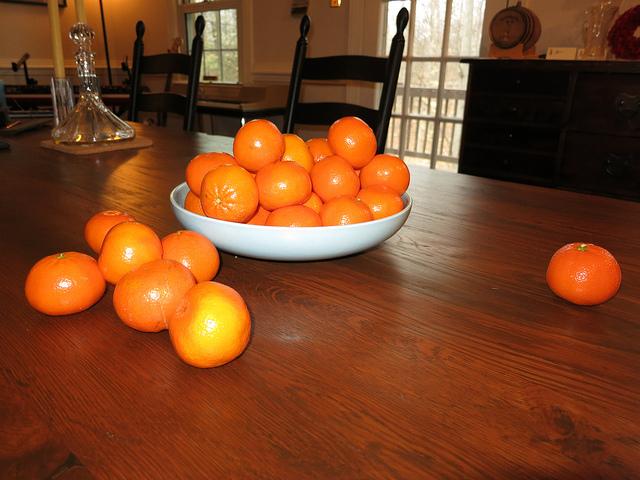Where is the bowl?
Give a very brief answer. Table. How many oranges have mold?
Answer briefly. 0. How many oranges are in the bowl?
Quick response, please. Many. 